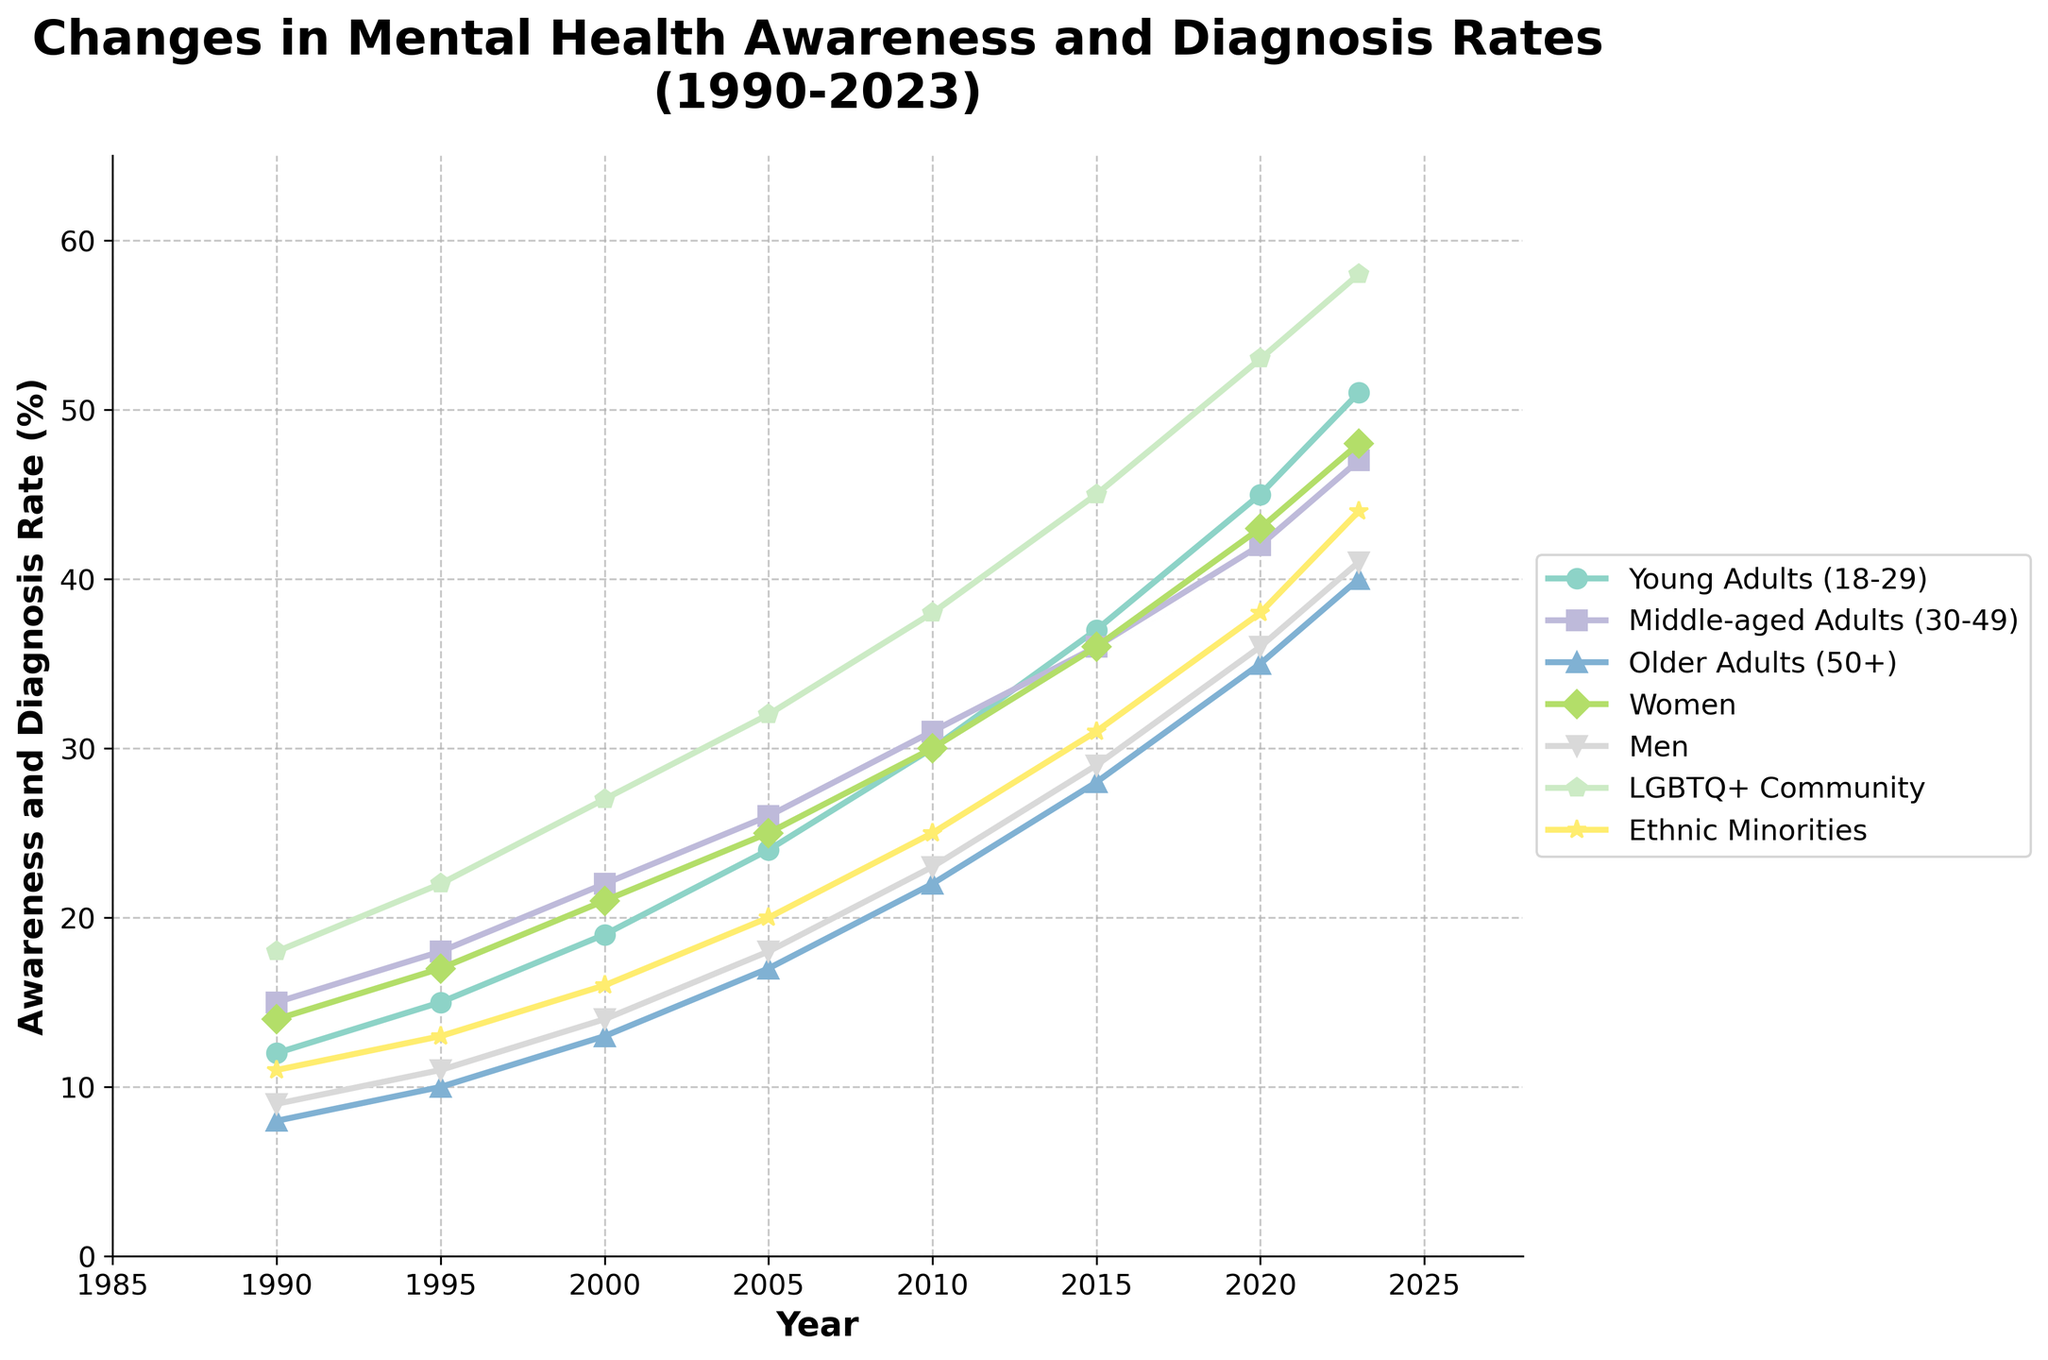What's the trend in mental health diagnosis rates for young adults (18-29) from 1990 to 2023? Observing the curve representing young adults (18-29), the rate starts at 12% in 1990 and rises steadily over time, reaching 51% in 2023.
Answer: Steady increase Which demographic group had the highest awareness and diagnosis rate in 2023? In 2023, the LGBTQ+ Community has the highest rate at 58%, observed as the topmost line in the final year on the graph.
Answer: LGBTQ+ Community How does the rate of mental health diagnosis for women compare to men in 2020? In 2020, the line for women is at 43%, and for men, it is at 36%. Thus, the rate for women is higher.
Answer: Women have a higher rate than men What is the difference between the awareness and diagnosis rates of older adults (50+) and young adults (18-29) in 2005? For 2005, older adults (50+) have a rate of 17% and young adults (18-29) have a rate of 24%. The difference is 24% - 17% = 7%.
Answer: 7% Which demographic shows the most rapid increase in awareness and diagnosis rates from 1990 to 2023? The line representing the LGBTQ+ Community rises from 18% in 1990 to 58% in 2023, an increase of 40%, which is the largest change among all demographics.
Answer: LGBTQ+ Community What is the average mental health diagnosis rate across all years for ethnic minorities? Adding up the values for ethnic minorities (11, 13, 16, 20, 25, 31, 38, 44) and dividing by the number of years (8) yields (198 / 8) = 24.75%.
Answer: 24.75% In 2010, which demographic had a rate closest to 30%? Checking the values in 2010, women have a rate of 30%, which is exactly 30%.
Answer: Women What’s the difference in the rate of mental health diagnosis between middle-aged adults (30-49) and older adults (50+) in 2023? For 2023, middle-aged adults (30-49) have a rate of 47%, and older adults (50+) have a rate of 40%. The difference is 47% - 40% = 7%.
Answer: 7% Did any demographic group rate decline or dip at any point from 1990 to 2023? Reviewing the lines for all groups, none show a visible decline at any point, indicating consistent increases.
Answer: No 